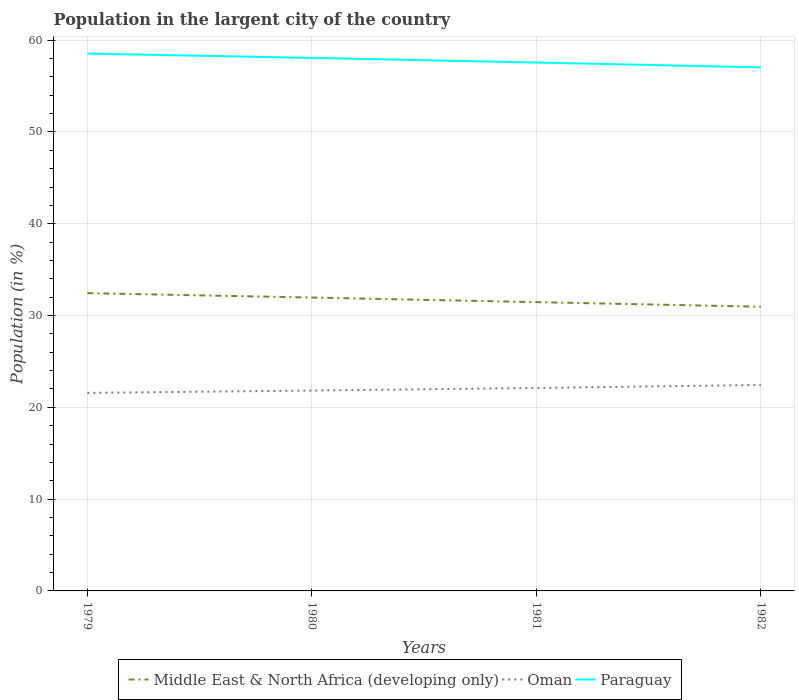Does the line corresponding to Paraguay intersect with the line corresponding to Middle East & North Africa (developing only)?
Your answer should be very brief. No. Across all years, what is the maximum percentage of population in the largent city in Oman?
Your answer should be compact. 21.57. What is the total percentage of population in the largent city in Paraguay in the graph?
Give a very brief answer. 0.52. What is the difference between the highest and the second highest percentage of population in the largent city in Oman?
Provide a short and direct response. 0.86. What is the difference between the highest and the lowest percentage of population in the largent city in Oman?
Your answer should be very brief. 2. How many lines are there?
Your response must be concise. 3. How many years are there in the graph?
Your response must be concise. 4. What is the difference between two consecutive major ticks on the Y-axis?
Provide a succinct answer. 10. Does the graph contain any zero values?
Provide a short and direct response. No. Where does the legend appear in the graph?
Make the answer very short. Bottom center. How many legend labels are there?
Offer a terse response. 3. How are the legend labels stacked?
Make the answer very short. Horizontal. What is the title of the graph?
Your response must be concise. Population in the largent city of the country. Does "Georgia" appear as one of the legend labels in the graph?
Offer a terse response. No. What is the label or title of the X-axis?
Provide a short and direct response. Years. What is the label or title of the Y-axis?
Offer a terse response. Population (in %). What is the Population (in %) of Middle East & North Africa (developing only) in 1979?
Keep it short and to the point. 32.44. What is the Population (in %) of Oman in 1979?
Offer a terse response. 21.57. What is the Population (in %) in Paraguay in 1979?
Give a very brief answer. 58.54. What is the Population (in %) in Middle East & North Africa (developing only) in 1980?
Make the answer very short. 31.96. What is the Population (in %) of Oman in 1980?
Your answer should be compact. 21.83. What is the Population (in %) of Paraguay in 1980?
Your answer should be compact. 58.07. What is the Population (in %) of Middle East & North Africa (developing only) in 1981?
Provide a succinct answer. 31.46. What is the Population (in %) of Oman in 1981?
Ensure brevity in your answer.  22.11. What is the Population (in %) in Paraguay in 1981?
Make the answer very short. 57.56. What is the Population (in %) in Middle East & North Africa (developing only) in 1982?
Make the answer very short. 30.96. What is the Population (in %) of Oman in 1982?
Make the answer very short. 22.44. What is the Population (in %) of Paraguay in 1982?
Keep it short and to the point. 57.04. Across all years, what is the maximum Population (in %) of Middle East & North Africa (developing only)?
Ensure brevity in your answer.  32.44. Across all years, what is the maximum Population (in %) in Oman?
Keep it short and to the point. 22.44. Across all years, what is the maximum Population (in %) of Paraguay?
Provide a short and direct response. 58.54. Across all years, what is the minimum Population (in %) in Middle East & North Africa (developing only)?
Your answer should be compact. 30.96. Across all years, what is the minimum Population (in %) in Oman?
Keep it short and to the point. 21.57. Across all years, what is the minimum Population (in %) of Paraguay?
Offer a very short reply. 57.04. What is the total Population (in %) in Middle East & North Africa (developing only) in the graph?
Provide a short and direct response. 126.81. What is the total Population (in %) in Oman in the graph?
Provide a succinct answer. 87.94. What is the total Population (in %) in Paraguay in the graph?
Offer a very short reply. 231.2. What is the difference between the Population (in %) in Middle East & North Africa (developing only) in 1979 and that in 1980?
Your answer should be compact. 0.48. What is the difference between the Population (in %) in Oman in 1979 and that in 1980?
Offer a very short reply. -0.25. What is the difference between the Population (in %) in Paraguay in 1979 and that in 1980?
Your answer should be very brief. 0.47. What is the difference between the Population (in %) of Middle East & North Africa (developing only) in 1979 and that in 1981?
Keep it short and to the point. 0.98. What is the difference between the Population (in %) of Oman in 1979 and that in 1981?
Offer a very short reply. -0.53. What is the difference between the Population (in %) in Paraguay in 1979 and that in 1981?
Your answer should be very brief. 0.98. What is the difference between the Population (in %) of Middle East & North Africa (developing only) in 1979 and that in 1982?
Offer a very short reply. 1.48. What is the difference between the Population (in %) of Oman in 1979 and that in 1982?
Provide a short and direct response. -0.86. What is the difference between the Population (in %) of Paraguay in 1979 and that in 1982?
Offer a very short reply. 1.5. What is the difference between the Population (in %) in Middle East & North Africa (developing only) in 1980 and that in 1981?
Your response must be concise. 0.5. What is the difference between the Population (in %) of Oman in 1980 and that in 1981?
Your answer should be compact. -0.28. What is the difference between the Population (in %) of Paraguay in 1980 and that in 1981?
Provide a short and direct response. 0.5. What is the difference between the Population (in %) of Oman in 1980 and that in 1982?
Give a very brief answer. -0.61. What is the difference between the Population (in %) in Paraguay in 1980 and that in 1982?
Provide a succinct answer. 1.03. What is the difference between the Population (in %) in Middle East & North Africa (developing only) in 1981 and that in 1982?
Make the answer very short. 0.5. What is the difference between the Population (in %) in Oman in 1981 and that in 1982?
Provide a succinct answer. -0.33. What is the difference between the Population (in %) of Paraguay in 1981 and that in 1982?
Give a very brief answer. 0.52. What is the difference between the Population (in %) of Middle East & North Africa (developing only) in 1979 and the Population (in %) of Oman in 1980?
Ensure brevity in your answer.  10.61. What is the difference between the Population (in %) in Middle East & North Africa (developing only) in 1979 and the Population (in %) in Paraguay in 1980?
Your answer should be very brief. -25.63. What is the difference between the Population (in %) in Oman in 1979 and the Population (in %) in Paraguay in 1980?
Provide a short and direct response. -36.49. What is the difference between the Population (in %) of Middle East & North Africa (developing only) in 1979 and the Population (in %) of Oman in 1981?
Provide a succinct answer. 10.33. What is the difference between the Population (in %) of Middle East & North Africa (developing only) in 1979 and the Population (in %) of Paraguay in 1981?
Ensure brevity in your answer.  -25.12. What is the difference between the Population (in %) in Oman in 1979 and the Population (in %) in Paraguay in 1981?
Provide a succinct answer. -35.99. What is the difference between the Population (in %) of Middle East & North Africa (developing only) in 1979 and the Population (in %) of Oman in 1982?
Offer a very short reply. 10. What is the difference between the Population (in %) in Middle East & North Africa (developing only) in 1979 and the Population (in %) in Paraguay in 1982?
Provide a succinct answer. -24.6. What is the difference between the Population (in %) of Oman in 1979 and the Population (in %) of Paraguay in 1982?
Your answer should be very brief. -35.46. What is the difference between the Population (in %) of Middle East & North Africa (developing only) in 1980 and the Population (in %) of Oman in 1981?
Keep it short and to the point. 9.85. What is the difference between the Population (in %) of Middle East & North Africa (developing only) in 1980 and the Population (in %) of Paraguay in 1981?
Your answer should be very brief. -25.6. What is the difference between the Population (in %) in Oman in 1980 and the Population (in %) in Paraguay in 1981?
Ensure brevity in your answer.  -35.74. What is the difference between the Population (in %) of Middle East & North Africa (developing only) in 1980 and the Population (in %) of Oman in 1982?
Offer a very short reply. 9.52. What is the difference between the Population (in %) in Middle East & North Africa (developing only) in 1980 and the Population (in %) in Paraguay in 1982?
Ensure brevity in your answer.  -25.08. What is the difference between the Population (in %) of Oman in 1980 and the Population (in %) of Paraguay in 1982?
Make the answer very short. -35.21. What is the difference between the Population (in %) in Middle East & North Africa (developing only) in 1981 and the Population (in %) in Oman in 1982?
Your answer should be very brief. 9.02. What is the difference between the Population (in %) of Middle East & North Africa (developing only) in 1981 and the Population (in %) of Paraguay in 1982?
Your response must be concise. -25.58. What is the difference between the Population (in %) of Oman in 1981 and the Population (in %) of Paraguay in 1982?
Keep it short and to the point. -34.93. What is the average Population (in %) in Middle East & North Africa (developing only) per year?
Provide a succinct answer. 31.7. What is the average Population (in %) in Oman per year?
Make the answer very short. 21.99. What is the average Population (in %) of Paraguay per year?
Keep it short and to the point. 57.8. In the year 1979, what is the difference between the Population (in %) of Middle East & North Africa (developing only) and Population (in %) of Oman?
Keep it short and to the point. 10.87. In the year 1979, what is the difference between the Population (in %) of Middle East & North Africa (developing only) and Population (in %) of Paraguay?
Your response must be concise. -26.1. In the year 1979, what is the difference between the Population (in %) in Oman and Population (in %) in Paraguay?
Provide a succinct answer. -36.97. In the year 1980, what is the difference between the Population (in %) of Middle East & North Africa (developing only) and Population (in %) of Oman?
Offer a very short reply. 10.13. In the year 1980, what is the difference between the Population (in %) of Middle East & North Africa (developing only) and Population (in %) of Paraguay?
Keep it short and to the point. -26.11. In the year 1980, what is the difference between the Population (in %) of Oman and Population (in %) of Paraguay?
Your response must be concise. -36.24. In the year 1981, what is the difference between the Population (in %) in Middle East & North Africa (developing only) and Population (in %) in Oman?
Give a very brief answer. 9.35. In the year 1981, what is the difference between the Population (in %) in Middle East & North Africa (developing only) and Population (in %) in Paraguay?
Your answer should be very brief. -26.1. In the year 1981, what is the difference between the Population (in %) of Oman and Population (in %) of Paraguay?
Your answer should be compact. -35.45. In the year 1982, what is the difference between the Population (in %) of Middle East & North Africa (developing only) and Population (in %) of Oman?
Provide a succinct answer. 8.52. In the year 1982, what is the difference between the Population (in %) in Middle East & North Africa (developing only) and Population (in %) in Paraguay?
Offer a very short reply. -26.08. In the year 1982, what is the difference between the Population (in %) of Oman and Population (in %) of Paraguay?
Your answer should be compact. -34.6. What is the ratio of the Population (in %) of Oman in 1979 to that in 1980?
Provide a short and direct response. 0.99. What is the ratio of the Population (in %) of Middle East & North Africa (developing only) in 1979 to that in 1981?
Your answer should be very brief. 1.03. What is the ratio of the Population (in %) of Oman in 1979 to that in 1981?
Offer a very short reply. 0.98. What is the ratio of the Population (in %) of Middle East & North Africa (developing only) in 1979 to that in 1982?
Provide a short and direct response. 1.05. What is the ratio of the Population (in %) of Oman in 1979 to that in 1982?
Keep it short and to the point. 0.96. What is the ratio of the Population (in %) in Paraguay in 1979 to that in 1982?
Keep it short and to the point. 1.03. What is the ratio of the Population (in %) in Middle East & North Africa (developing only) in 1980 to that in 1981?
Provide a short and direct response. 1.02. What is the ratio of the Population (in %) of Oman in 1980 to that in 1981?
Give a very brief answer. 0.99. What is the ratio of the Population (in %) of Paraguay in 1980 to that in 1981?
Offer a very short reply. 1.01. What is the ratio of the Population (in %) of Middle East & North Africa (developing only) in 1980 to that in 1982?
Make the answer very short. 1.03. What is the ratio of the Population (in %) of Oman in 1980 to that in 1982?
Your response must be concise. 0.97. What is the ratio of the Population (in %) of Paraguay in 1980 to that in 1982?
Ensure brevity in your answer.  1.02. What is the ratio of the Population (in %) in Middle East & North Africa (developing only) in 1981 to that in 1982?
Keep it short and to the point. 1.02. What is the ratio of the Population (in %) in Paraguay in 1981 to that in 1982?
Your answer should be very brief. 1.01. What is the difference between the highest and the second highest Population (in %) in Middle East & North Africa (developing only)?
Give a very brief answer. 0.48. What is the difference between the highest and the second highest Population (in %) in Oman?
Offer a terse response. 0.33. What is the difference between the highest and the second highest Population (in %) in Paraguay?
Offer a very short reply. 0.47. What is the difference between the highest and the lowest Population (in %) of Middle East & North Africa (developing only)?
Your response must be concise. 1.48. What is the difference between the highest and the lowest Population (in %) of Oman?
Offer a very short reply. 0.86. What is the difference between the highest and the lowest Population (in %) of Paraguay?
Provide a short and direct response. 1.5. 